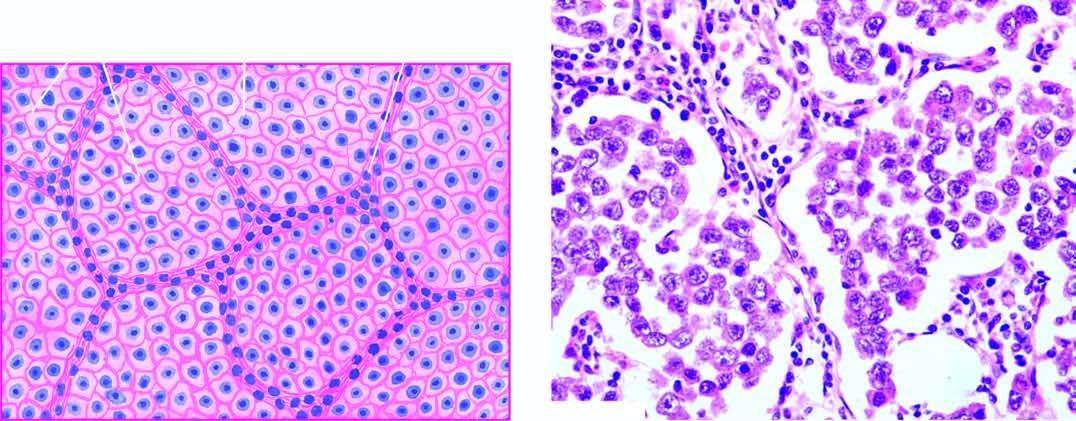does microscopy of the tumour show lobules of monomorphic seminoma cells separated by delicate fibrous stroma containing lymphocytic infiltration?
Answer the question using a single word or phrase. Yes 